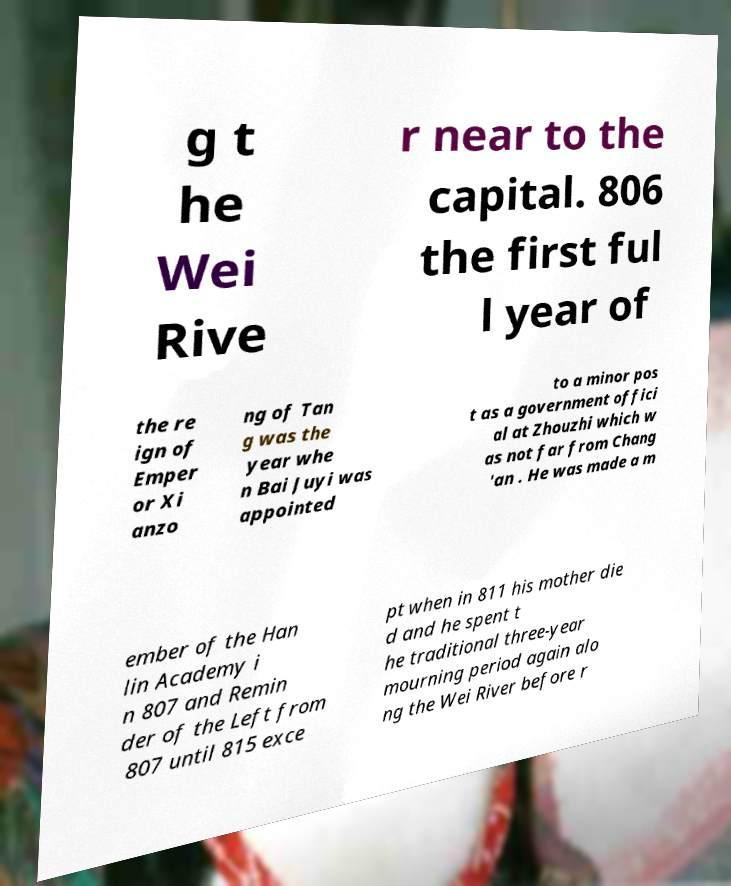What messages or text are displayed in this image? I need them in a readable, typed format. g t he Wei Rive r near to the capital. 806 the first ful l year of the re ign of Emper or Xi anzo ng of Tan g was the year whe n Bai Juyi was appointed to a minor pos t as a government offici al at Zhouzhi which w as not far from Chang 'an . He was made a m ember of the Han lin Academy i n 807 and Remin der of the Left from 807 until 815 exce pt when in 811 his mother die d and he spent t he traditional three-year mourning period again alo ng the Wei River before r 